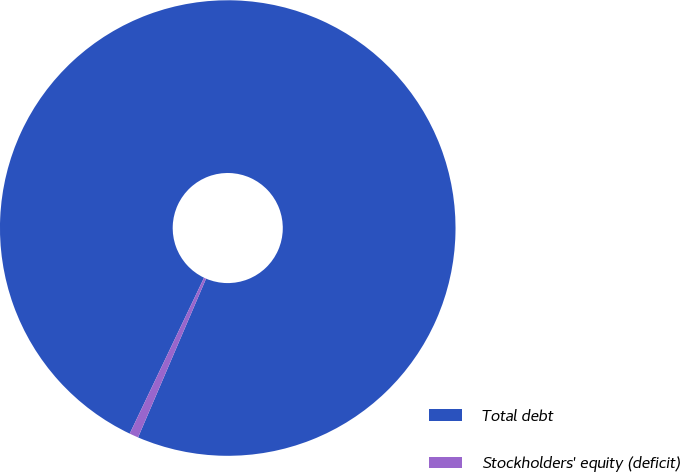<chart> <loc_0><loc_0><loc_500><loc_500><pie_chart><fcel>Total debt<fcel>Stockholders' equity (deficit)<nl><fcel>99.36%<fcel>0.64%<nl></chart> 